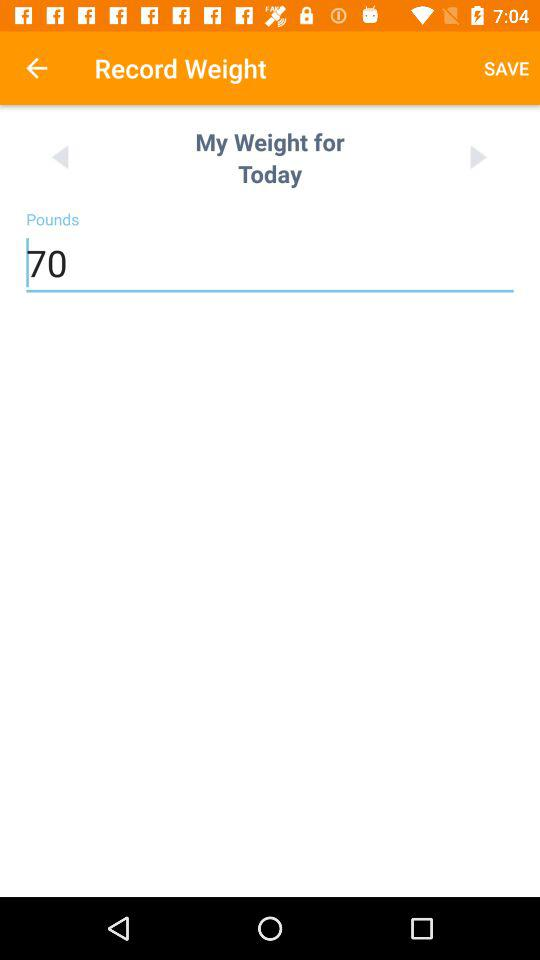Which is the selected day to record weight? The selected day is today. 